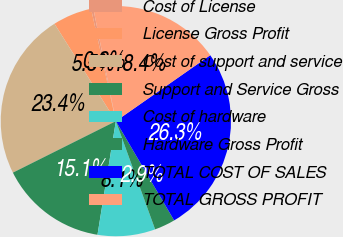Convert chart to OTSL. <chart><loc_0><loc_0><loc_500><loc_500><pie_chart><fcel>Cost of License<fcel>License Gross Profit<fcel>Cost of support and service<fcel>Support and Service Gross<fcel>Cost of hardware<fcel>Hardware Gross Profit<fcel>TOTAL COST OF SALES<fcel>TOTAL GROSS PROFIT<nl><fcel>0.31%<fcel>5.5%<fcel>23.43%<fcel>15.07%<fcel>8.09%<fcel>2.91%<fcel>26.26%<fcel>18.44%<nl></chart> 